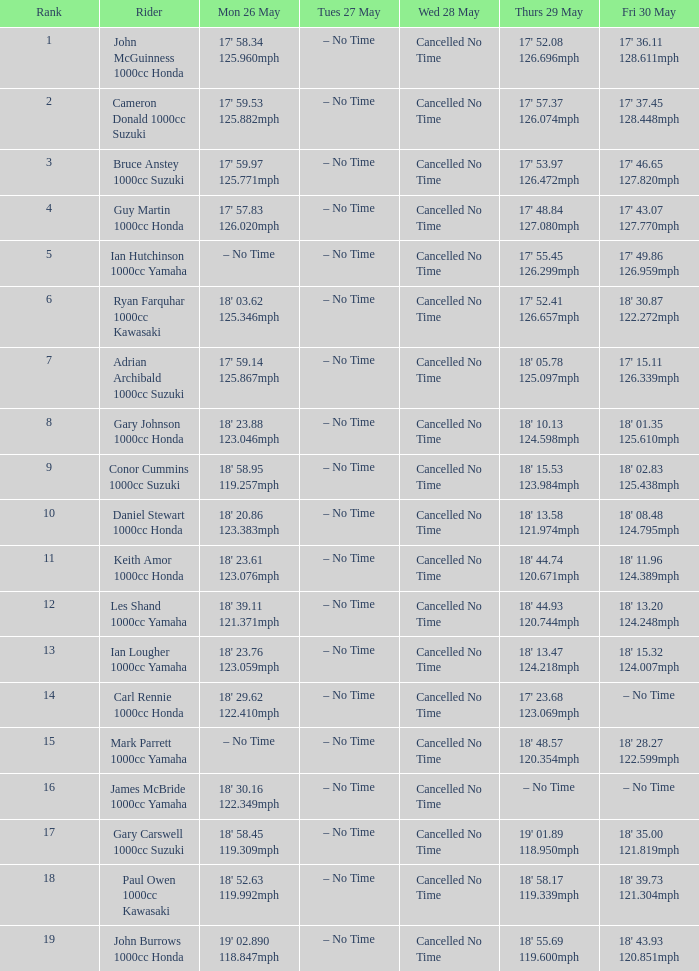What time is mon may 26 and fri may 30 is 18' 28.27 122.599mph? – No Time. 